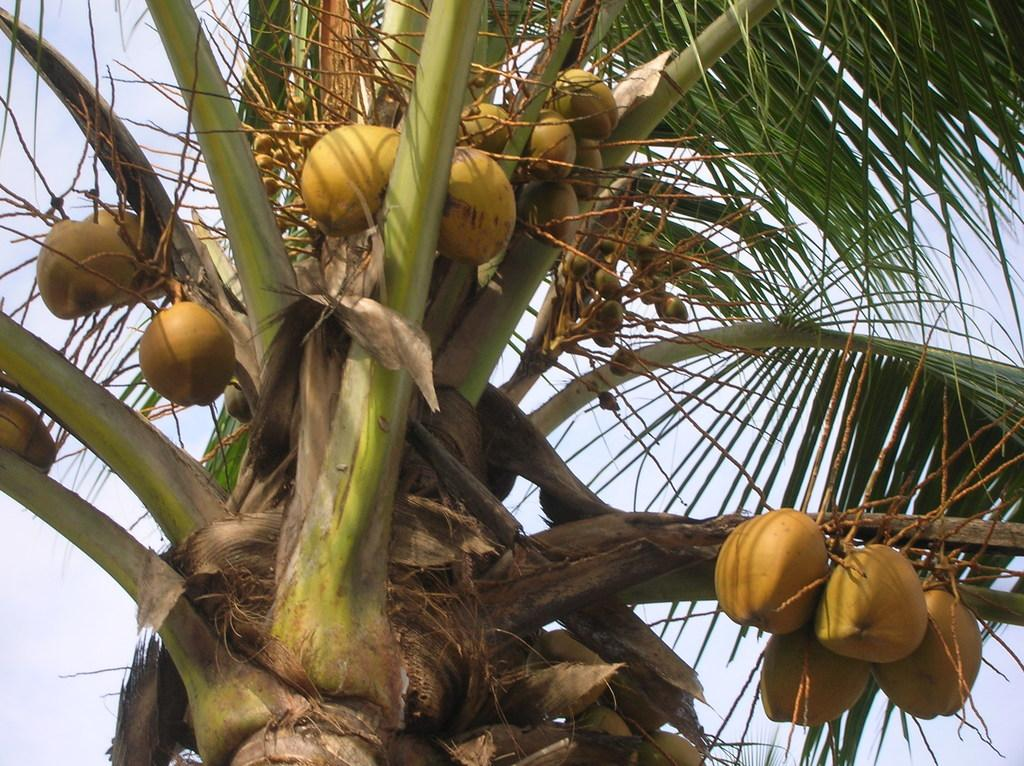What type of tree is in the picture? There is a coconut tree in the picture. How many coconuts are on the tree? The coconut tree has many coconuts. What can be seen in the background of the picture? The sky is visible in the background of the picture. What representative of the government can be seen in the picture? There is no representative of the government present in the picture; it features a coconut tree with many coconuts and a visible sky in the background. 